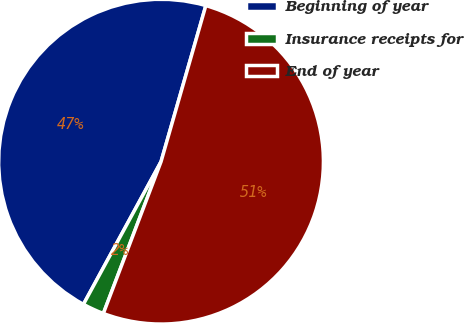Convert chart to OTSL. <chart><loc_0><loc_0><loc_500><loc_500><pie_chart><fcel>Beginning of year<fcel>Insurance receipts for<fcel>End of year<nl><fcel>46.52%<fcel>2.15%<fcel>51.33%<nl></chart> 